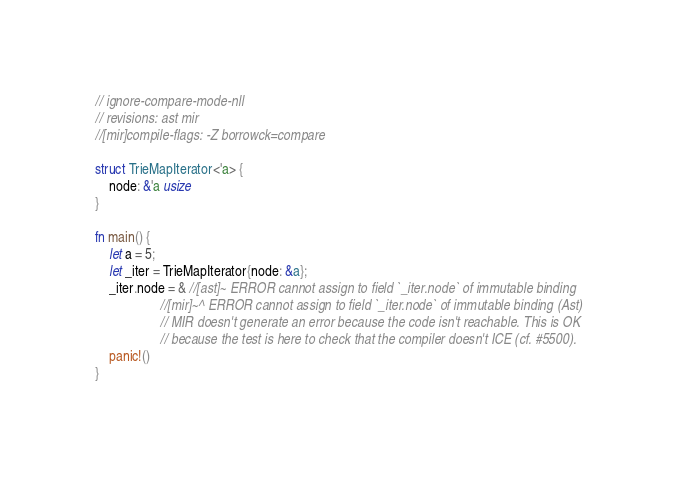<code> <loc_0><loc_0><loc_500><loc_500><_Rust_>// ignore-compare-mode-nll
// revisions: ast mir
//[mir]compile-flags: -Z borrowck=compare

struct TrieMapIterator<'a> {
    node: &'a usize
}

fn main() {
    let a = 5;
    let _iter = TrieMapIterator{node: &a};
    _iter.node = & //[ast]~ ERROR cannot assign to field `_iter.node` of immutable binding
                   //[mir]~^ ERROR cannot assign to field `_iter.node` of immutable binding (Ast)
                   // MIR doesn't generate an error because the code isn't reachable. This is OK
                   // because the test is here to check that the compiler doesn't ICE (cf. #5500).
    panic!()
}
</code> 